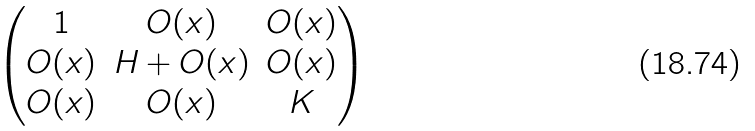Convert formula to latex. <formula><loc_0><loc_0><loc_500><loc_500>\begin{pmatrix} 1 & O ( x ) & O ( x ) \\ O ( x ) & H + O ( x ) & O ( x ) \\ O ( x ) & O ( x ) & K \end{pmatrix}</formula> 